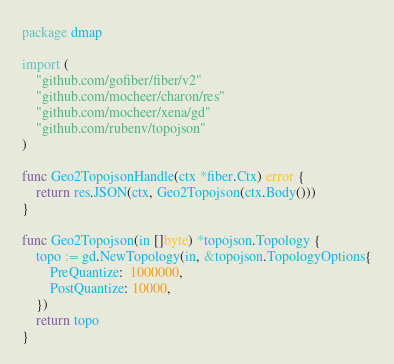<code> <loc_0><loc_0><loc_500><loc_500><_Go_>package dmap

import (
	"github.com/gofiber/fiber/v2"
	"github.com/mocheer/charon/res"
	"github.com/mocheer/xena/gd"
	"github.com/rubenv/topojson"
)

func Geo2TopojsonHandle(ctx *fiber.Ctx) error {
	return res.JSON(ctx, Geo2Topojson(ctx.Body()))
}

func Geo2Topojson(in []byte) *topojson.Topology {
	topo := gd.NewTopology(in, &topojson.TopologyOptions{
		PreQuantize:  1000000,
		PostQuantize: 10000,
	})
	return topo
}
</code> 